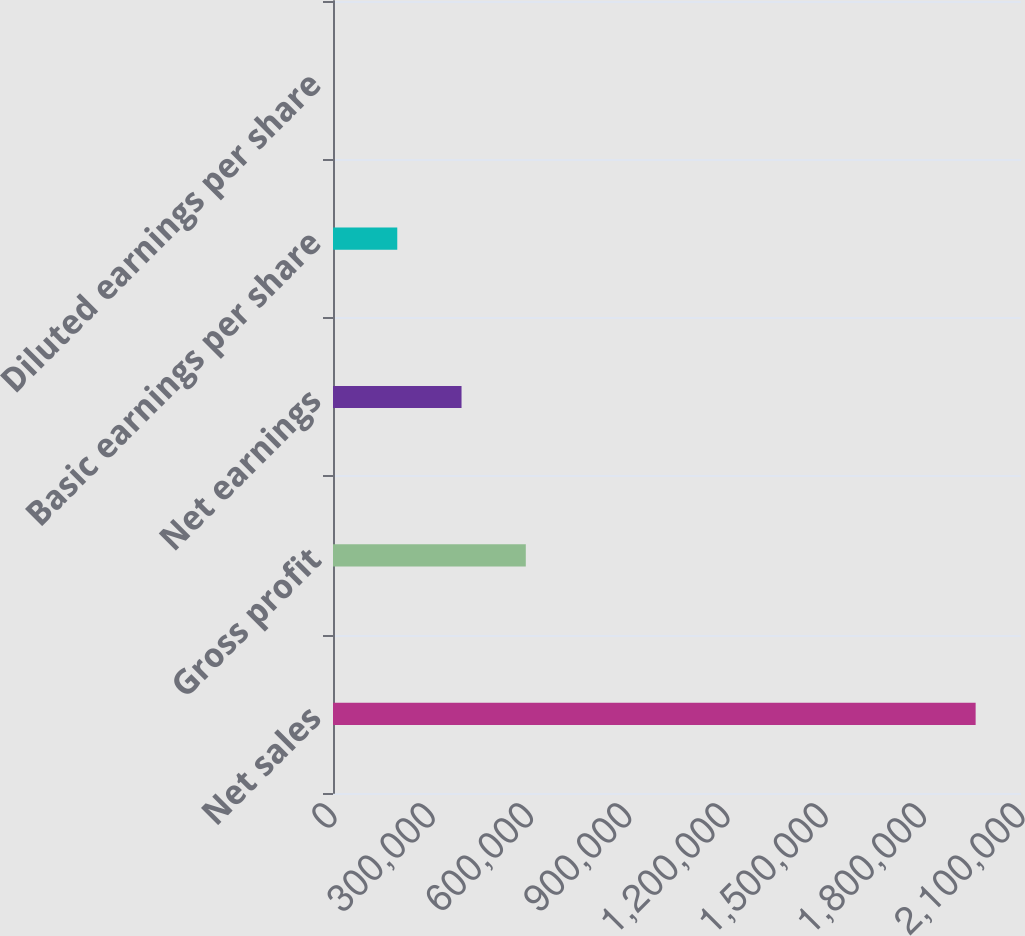Convert chart. <chart><loc_0><loc_0><loc_500><loc_500><bar_chart><fcel>Net sales<fcel>Gross profit<fcel>Net earnings<fcel>Basic earnings per share<fcel>Diluted earnings per share<nl><fcel>1.96154e+06<fcel>588462<fcel>392309<fcel>196155<fcel>1.63<nl></chart> 